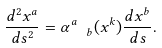Convert formula to latex. <formula><loc_0><loc_0><loc_500><loc_500>\frac { d ^ { 2 } x ^ { a } } { d s ^ { 2 } } = { \alpha } ^ { a } _ { \ \ b } ( x ^ { k } ) \frac { d x ^ { b } } { d s } .</formula> 